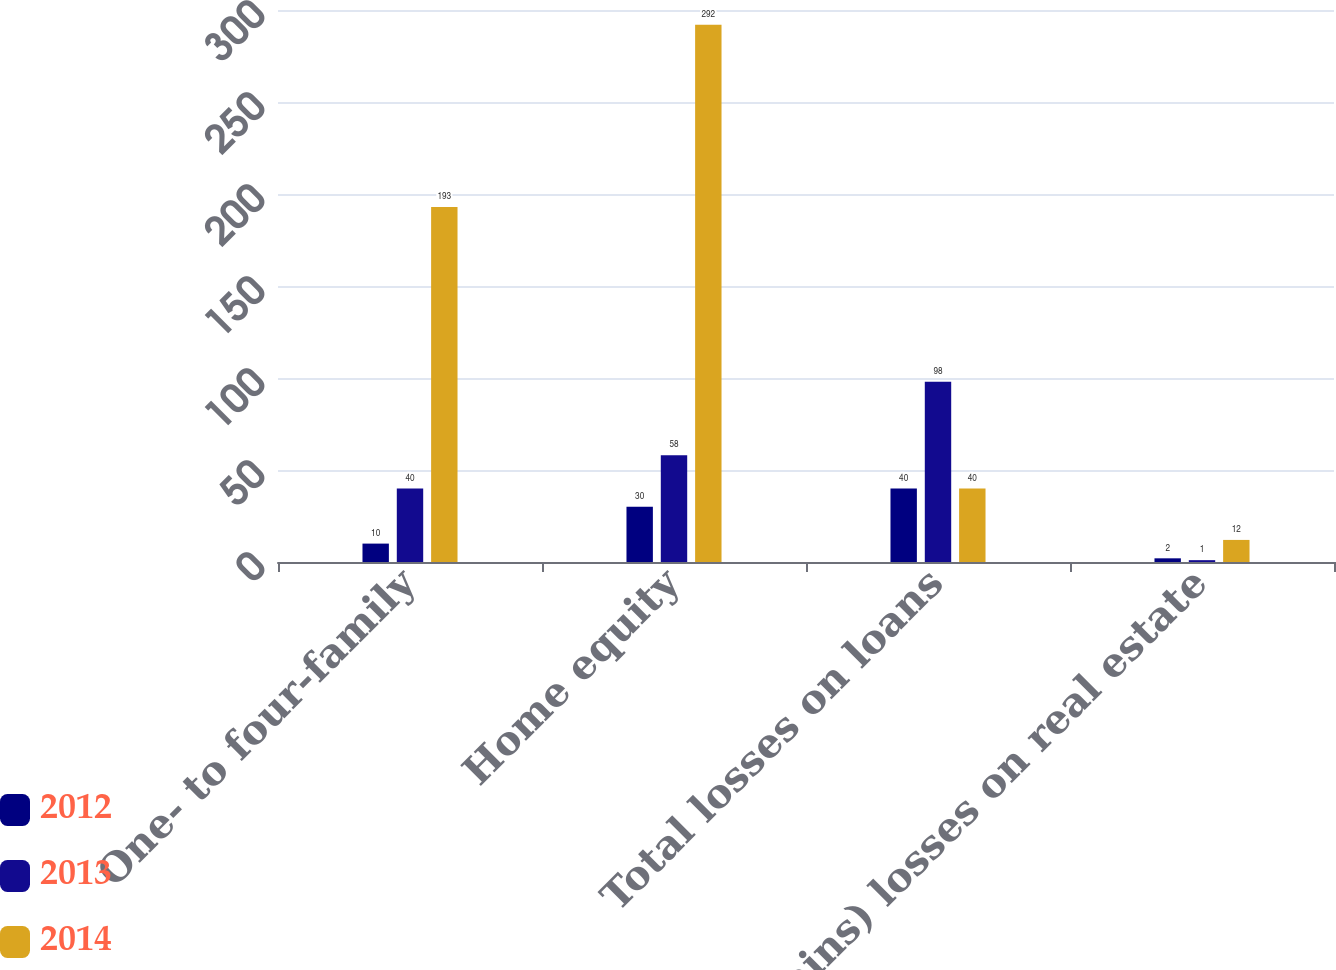Convert chart. <chart><loc_0><loc_0><loc_500><loc_500><stacked_bar_chart><ecel><fcel>One- to four-family<fcel>Home equity<fcel>Total losses on loans<fcel>(Gains) losses on real estate<nl><fcel>2012<fcel>10<fcel>30<fcel>40<fcel>2<nl><fcel>2013<fcel>40<fcel>58<fcel>98<fcel>1<nl><fcel>2014<fcel>193<fcel>292<fcel>40<fcel>12<nl></chart> 